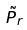Convert formula to latex. <formula><loc_0><loc_0><loc_500><loc_500>\tilde { P } _ { r }</formula> 